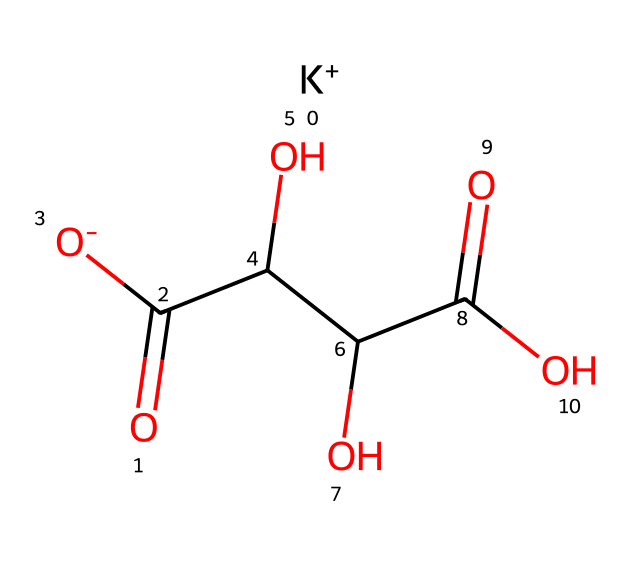What is the molecular formula of potassium bitartrate? The SMILES representation shows that the compound contains one potassium ion (K+), along with carbon (C), hydrogen (H), and oxygen (O) atoms. Counting these, we find the molecular formula is C4H5KO6.
Answer: C4H5KO6 How many carbon atoms are present in potassium bitartrate? By analyzing the SMILES structure, we identify four 'C' symbols, which represent the carbon atoms in the molecule.
Answer: 4 What type of functional groups are present in potassium bitartrate? The structure contains carboxylic acid groups (due to the presence of -COOH) and hydroxyl groups (-OH) based on the sequence of atoms shown in the SMILES.
Answer: carboxylic acid and hydroxyl Is potassium bitartrate a salt or an acid? The presence of the potassium ion (K+) and the carboxylate groups indicates that it is classified as a salt derived from the deprotonation of tartaric acid.
Answer: salt What is the significance of potassium in potassium bitartrate? Potassium acts as a counterion that balances the negative charge from the deprotonated acid groups, thus stabilizing the overall structure and its ionic character.
Answer: stabilizing agent How many hydroxyl groups are in potassium bitartrate? The SMILES shows two 'O' atoms connected to the carbon structure where the -OH functional groups are represented, indicating two hydroxyl (-OH) groups.
Answer: 2 